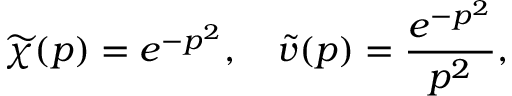Convert formula to latex. <formula><loc_0><loc_0><loc_500><loc_500>\widetilde { \chi } ( p ) = e ^ { - p ^ { 2 } } , \quad \widetilde { v } ( p ) = \frac { e ^ { - p ^ { 2 } } } { p ^ { 2 } } ,</formula> 